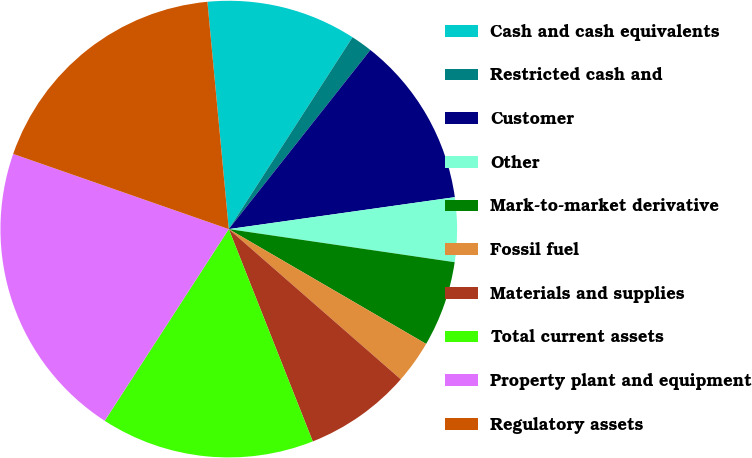Convert chart. <chart><loc_0><loc_0><loc_500><loc_500><pie_chart><fcel>Cash and cash equivalents<fcel>Restricted cash and<fcel>Customer<fcel>Other<fcel>Mark-to-market derivative<fcel>Fossil fuel<fcel>Materials and supplies<fcel>Total current assets<fcel>Property plant and equipment<fcel>Regulatory assets<nl><fcel>10.61%<fcel>1.53%<fcel>12.12%<fcel>4.55%<fcel>6.07%<fcel>3.04%<fcel>7.58%<fcel>15.14%<fcel>21.2%<fcel>18.17%<nl></chart> 